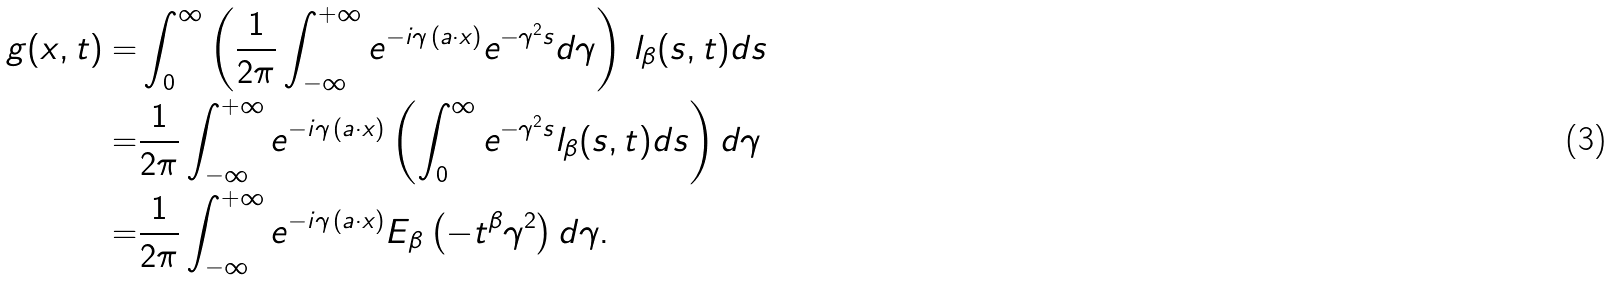<formula> <loc_0><loc_0><loc_500><loc_500>g ( x , t ) = & \int _ { 0 } ^ { \infty } \left ( \frac { 1 } { 2 \pi } \int _ { - \infty } ^ { + \infty } e ^ { - i \gamma \, ( a \cdot x ) } e ^ { - \gamma ^ { 2 } s } d \gamma \right ) \, l _ { \beta } ( s , t ) d s \\ = & \frac { 1 } { 2 \pi } \int _ { - \infty } ^ { + \infty } e ^ { - i \gamma \, ( a \cdot x ) } \left ( \int _ { 0 } ^ { \infty } e ^ { - \gamma ^ { 2 } s } l _ { \beta } ( s , t ) d s \right ) d \gamma \\ = & \frac { 1 } { 2 \pi } \int _ { - \infty } ^ { + \infty } e ^ { - i \gamma \, ( a \cdot x ) } E _ { \beta } \left ( - t ^ { \beta } \gamma ^ { 2 } \right ) d \gamma .</formula> 